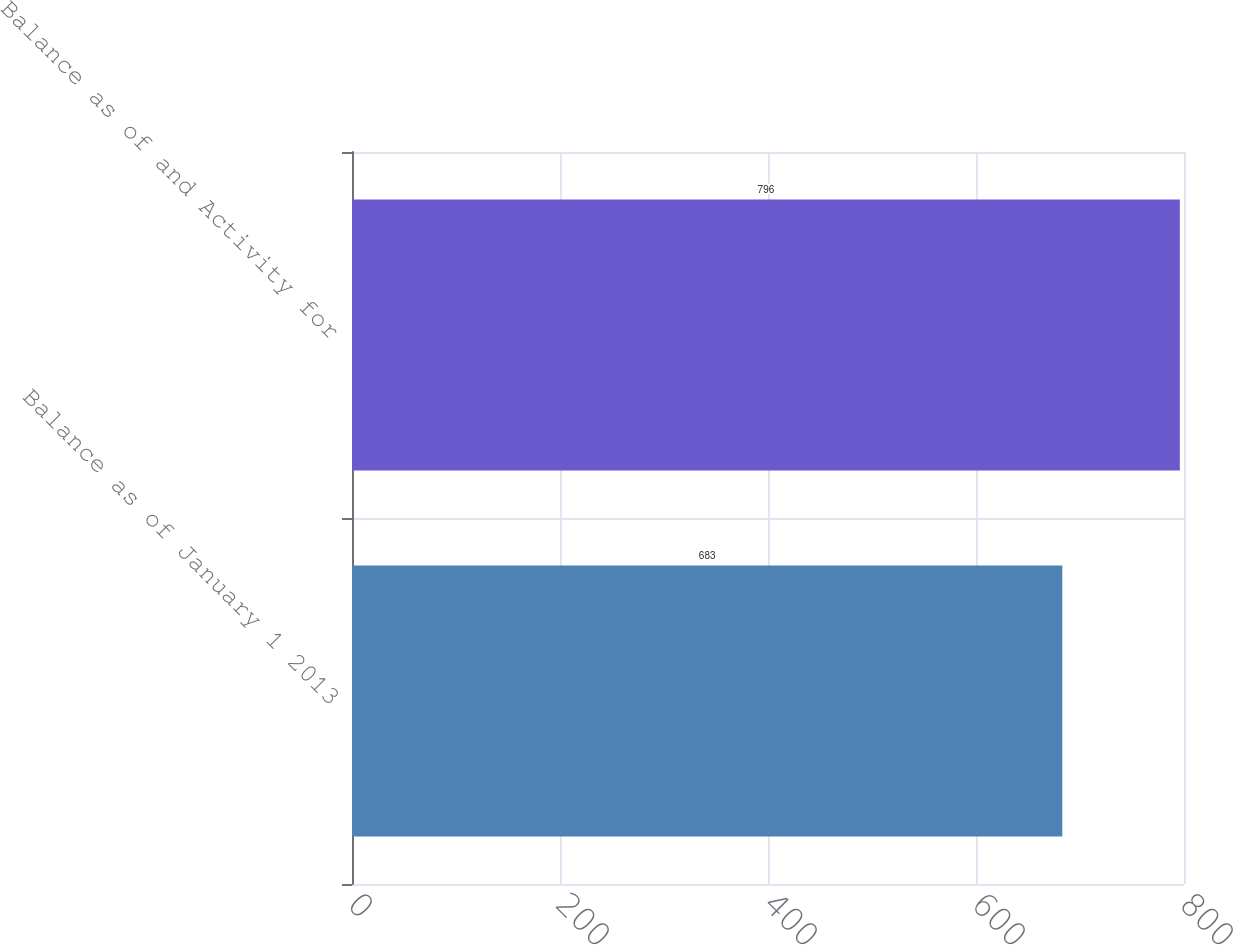Convert chart. <chart><loc_0><loc_0><loc_500><loc_500><bar_chart><fcel>Balance as of January 1 2013<fcel>Balance as of and Activity for<nl><fcel>683<fcel>796<nl></chart> 